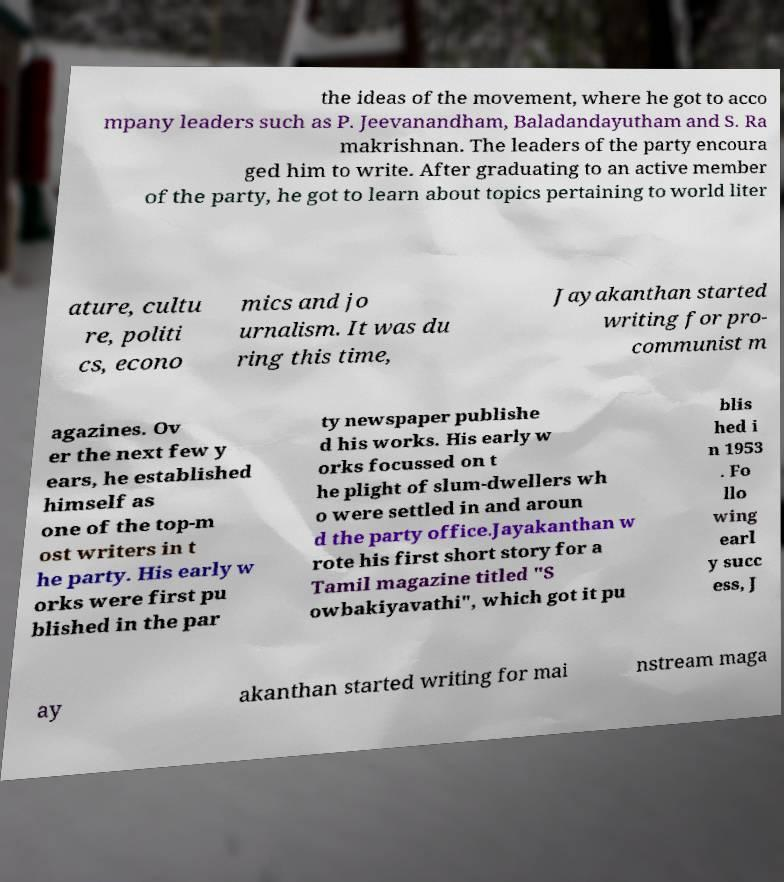Please read and relay the text visible in this image. What does it say? the ideas of the movement, where he got to acco mpany leaders such as P. Jeevanandham, Baladandayutham and S. Ra makrishnan. The leaders of the party encoura ged him to write. After graduating to an active member of the party, he got to learn about topics pertaining to world liter ature, cultu re, politi cs, econo mics and jo urnalism. It was du ring this time, Jayakanthan started writing for pro- communist m agazines. Ov er the next few y ears, he established himself as one of the top-m ost writers in t he party. His early w orks were first pu blished in the par ty newspaper publishe d his works. His early w orks focussed on t he plight of slum-dwellers wh o were settled in and aroun d the party office.Jayakanthan w rote his first short story for a Tamil magazine titled "S owbakiyavathi", which got it pu blis hed i n 1953 . Fo llo wing earl y succ ess, J ay akanthan started writing for mai nstream maga 